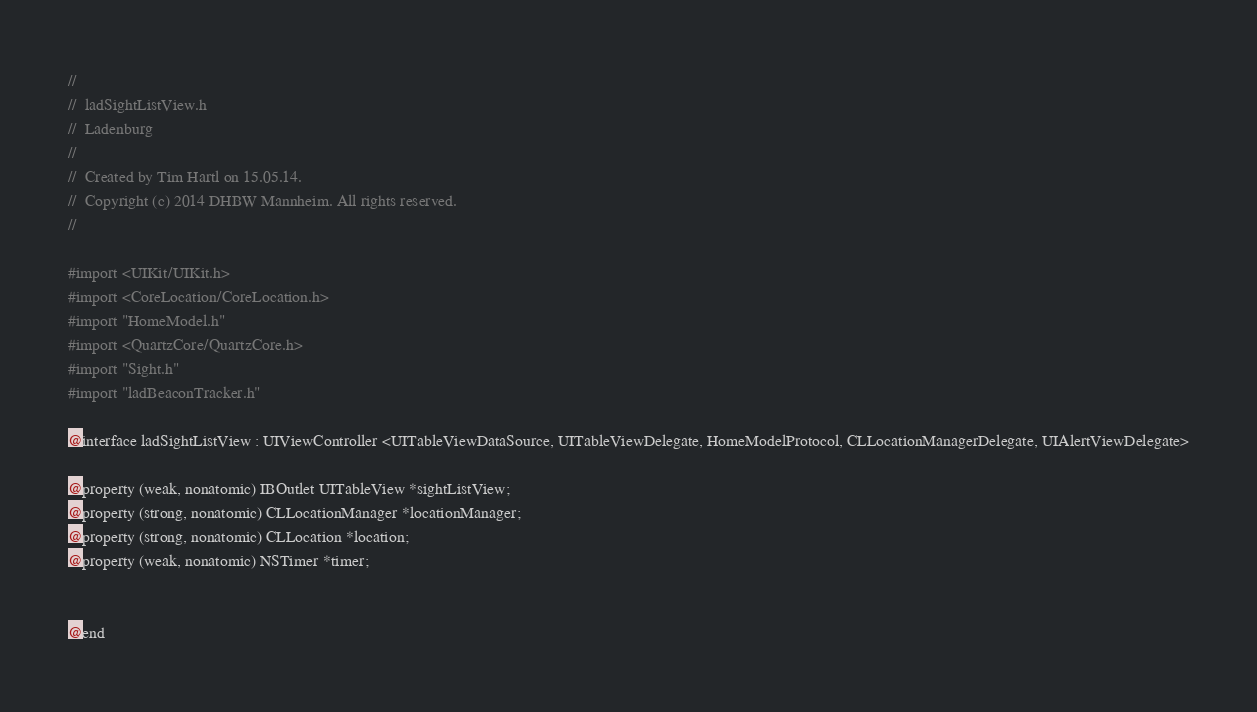Convert code to text. <code><loc_0><loc_0><loc_500><loc_500><_C_>//
//  ladSightListView.h
//  Ladenburg
//
//  Created by Tim Hartl on 15.05.14.
//  Copyright (c) 2014 DHBW Mannheim. All rights reserved.
//

#import <UIKit/UIKit.h>
#import <CoreLocation/CoreLocation.h>
#import "HomeModel.h"
#import <QuartzCore/QuartzCore.h>
#import "Sight.h"
#import "ladBeaconTracker.h"

@interface ladSightListView : UIViewController <UITableViewDataSource, UITableViewDelegate, HomeModelProtocol, CLLocationManagerDelegate, UIAlertViewDelegate>

@property (weak, nonatomic) IBOutlet UITableView *sightListView;
@property (strong, nonatomic) CLLocationManager *locationManager;
@property (strong, nonatomic) CLLocation *location;
@property (weak, nonatomic) NSTimer *timer;


@end</code> 